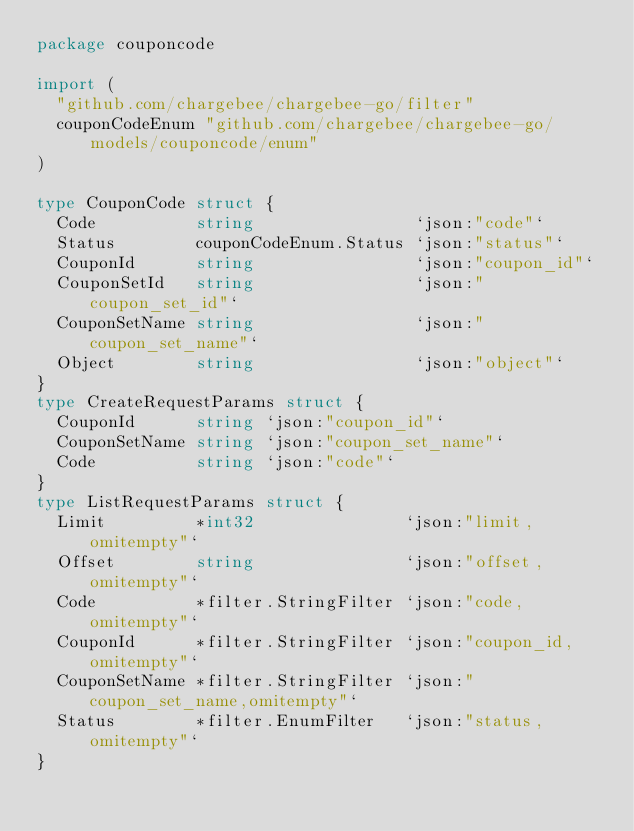Convert code to text. <code><loc_0><loc_0><loc_500><loc_500><_Go_>package couponcode

import (
	"github.com/chargebee/chargebee-go/filter"
	couponCodeEnum "github.com/chargebee/chargebee-go/models/couponcode/enum"
)

type CouponCode struct {
	Code          string                `json:"code"`
	Status        couponCodeEnum.Status `json:"status"`
	CouponId      string                `json:"coupon_id"`
	CouponSetId   string                `json:"coupon_set_id"`
	CouponSetName string                `json:"coupon_set_name"`
	Object        string                `json:"object"`
}
type CreateRequestParams struct {
	CouponId      string `json:"coupon_id"`
	CouponSetName string `json:"coupon_set_name"`
	Code          string `json:"code"`
}
type ListRequestParams struct {
	Limit         *int32               `json:"limit,omitempty"`
	Offset        string               `json:"offset,omitempty"`
	Code          *filter.StringFilter `json:"code,omitempty"`
	CouponId      *filter.StringFilter `json:"coupon_id,omitempty"`
	CouponSetName *filter.StringFilter `json:"coupon_set_name,omitempty"`
	Status        *filter.EnumFilter   `json:"status,omitempty"`
}
</code> 